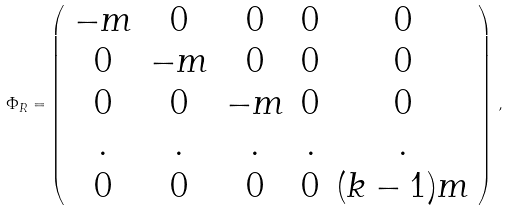<formula> <loc_0><loc_0><loc_500><loc_500>\Phi _ { R } = \left ( \begin{array} { c c c c c } - m & 0 & 0 & 0 & 0 \\ 0 & - m & 0 & 0 & 0 \\ 0 & 0 & - m & 0 & 0 \\ . & . & . & . & . \\ 0 & 0 & 0 & 0 & ( k - 1 ) m \end{array} \right ) \, ,</formula> 